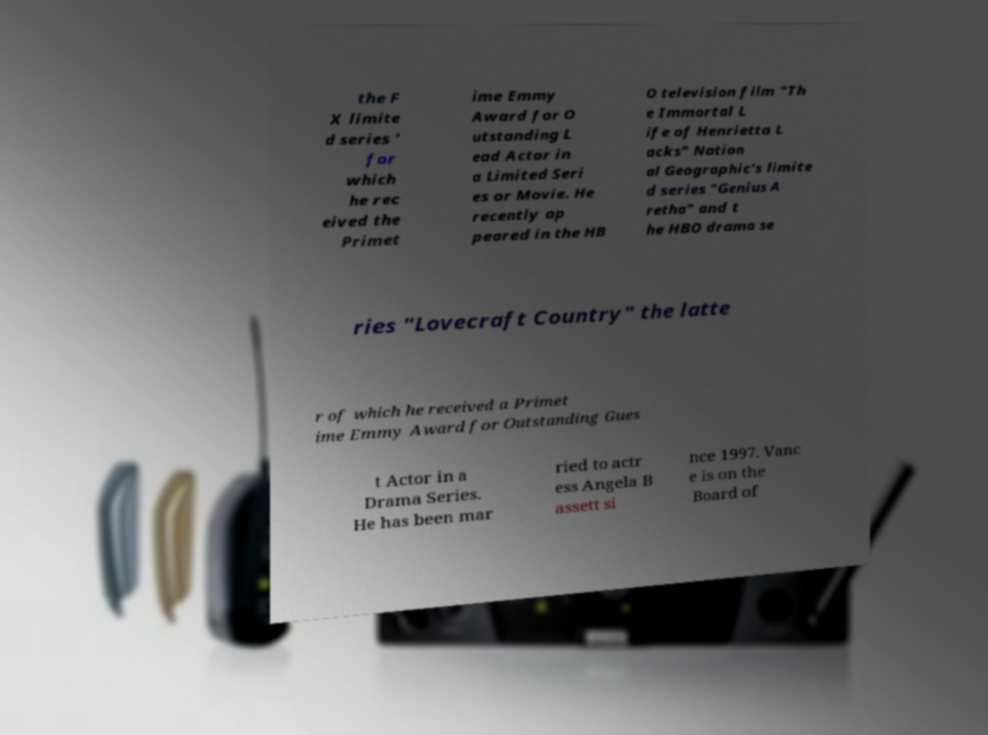Can you read and provide the text displayed in the image?This photo seems to have some interesting text. Can you extract and type it out for me? the F X limite d series ' for which he rec eived the Primet ime Emmy Award for O utstanding L ead Actor in a Limited Seri es or Movie. He recently ap peared in the HB O television film "Th e Immortal L ife of Henrietta L acks" Nation al Geographic's limite d series "Genius A retha" and t he HBO drama se ries "Lovecraft Country" the latte r of which he received a Primet ime Emmy Award for Outstanding Gues t Actor in a Drama Series. He has been mar ried to actr ess Angela B assett si nce 1997. Vanc e is on the Board of 